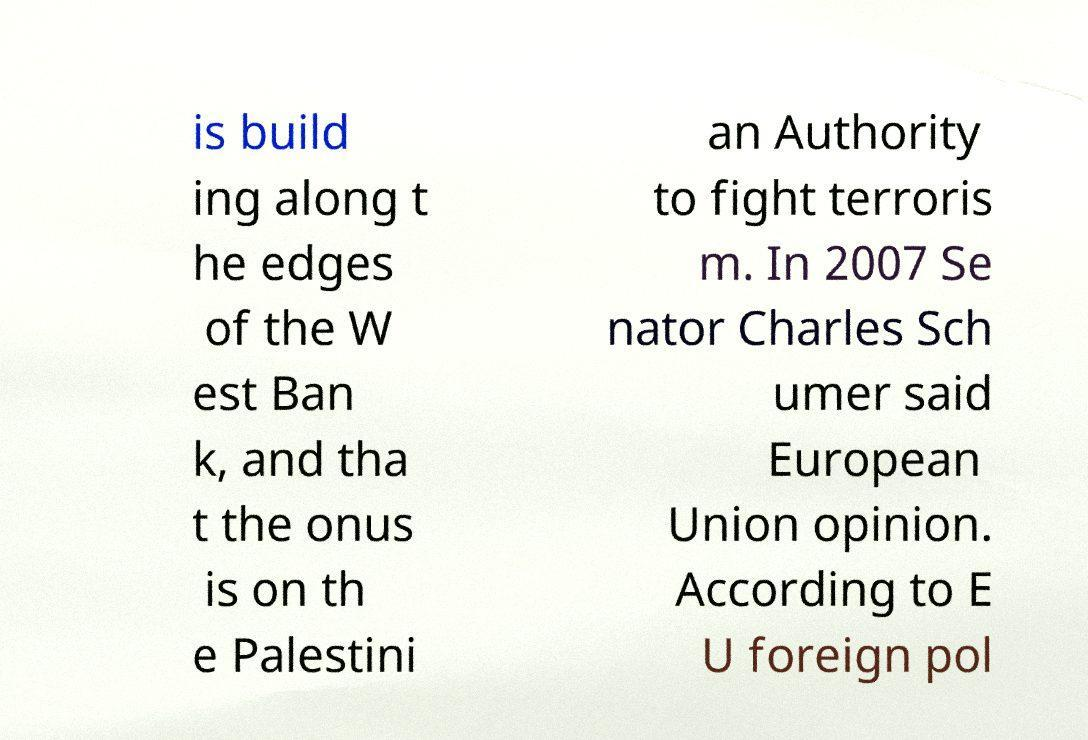Can you read and provide the text displayed in the image?This photo seems to have some interesting text. Can you extract and type it out for me? is build ing along t he edges of the W est Ban k, and tha t the onus is on th e Palestini an Authority to fight terroris m. In 2007 Se nator Charles Sch umer said European Union opinion. According to E U foreign pol 